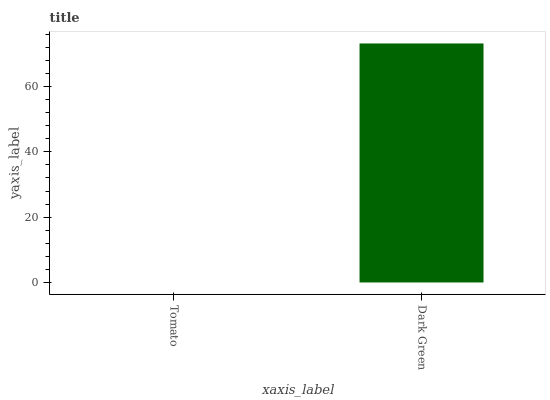Is Tomato the minimum?
Answer yes or no. Yes. Is Dark Green the maximum?
Answer yes or no. Yes. Is Dark Green the minimum?
Answer yes or no. No. Is Dark Green greater than Tomato?
Answer yes or no. Yes. Is Tomato less than Dark Green?
Answer yes or no. Yes. Is Tomato greater than Dark Green?
Answer yes or no. No. Is Dark Green less than Tomato?
Answer yes or no. No. Is Dark Green the high median?
Answer yes or no. Yes. Is Tomato the low median?
Answer yes or no. Yes. Is Tomato the high median?
Answer yes or no. No. Is Dark Green the low median?
Answer yes or no. No. 